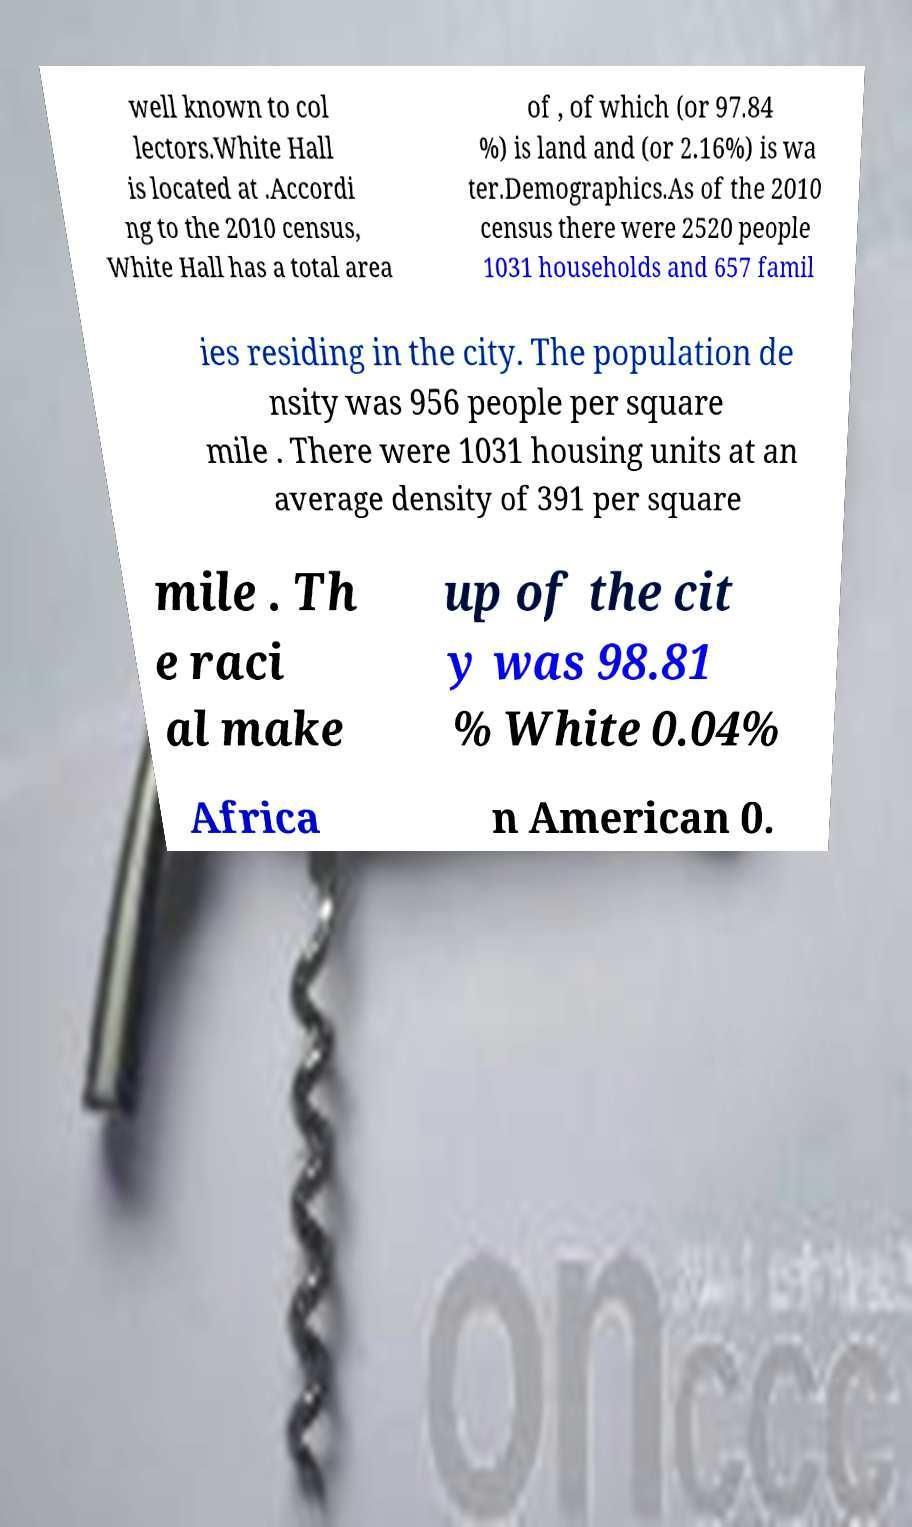Can you read and provide the text displayed in the image?This photo seems to have some interesting text. Can you extract and type it out for me? well known to col lectors.White Hall is located at .Accordi ng to the 2010 census, White Hall has a total area of , of which (or 97.84 %) is land and (or 2.16%) is wa ter.Demographics.As of the 2010 census there were 2520 people 1031 households and 657 famil ies residing in the city. The population de nsity was 956 people per square mile . There were 1031 housing units at an average density of 391 per square mile . Th e raci al make up of the cit y was 98.81 % White 0.04% Africa n American 0. 